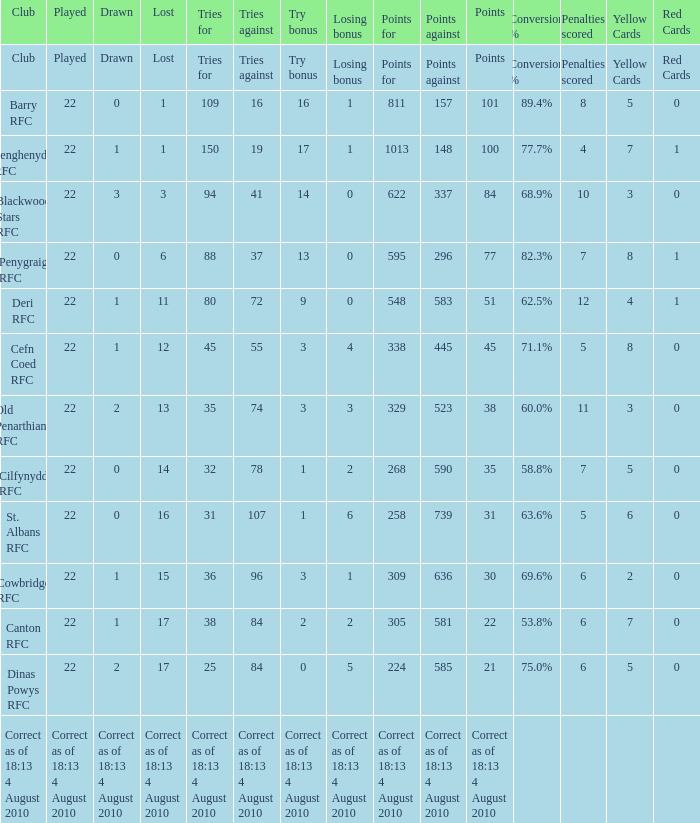What is the played number when tries against is 84, and drawn is 2? 22.0. 